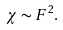Convert formula to latex. <formula><loc_0><loc_0><loc_500><loc_500>\chi \sim F ^ { 2 } .</formula> 